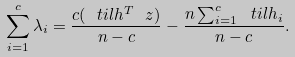Convert formula to latex. <formula><loc_0><loc_0><loc_500><loc_500>\sum _ { i = 1 } ^ { c } \lambda _ { i } = \frac { c ( \ t i l h ^ { T } \ z ) } { n - c } - \frac { n \sum _ { i = 1 } ^ { c } \ t i l h _ { i } } { n - c } .</formula> 